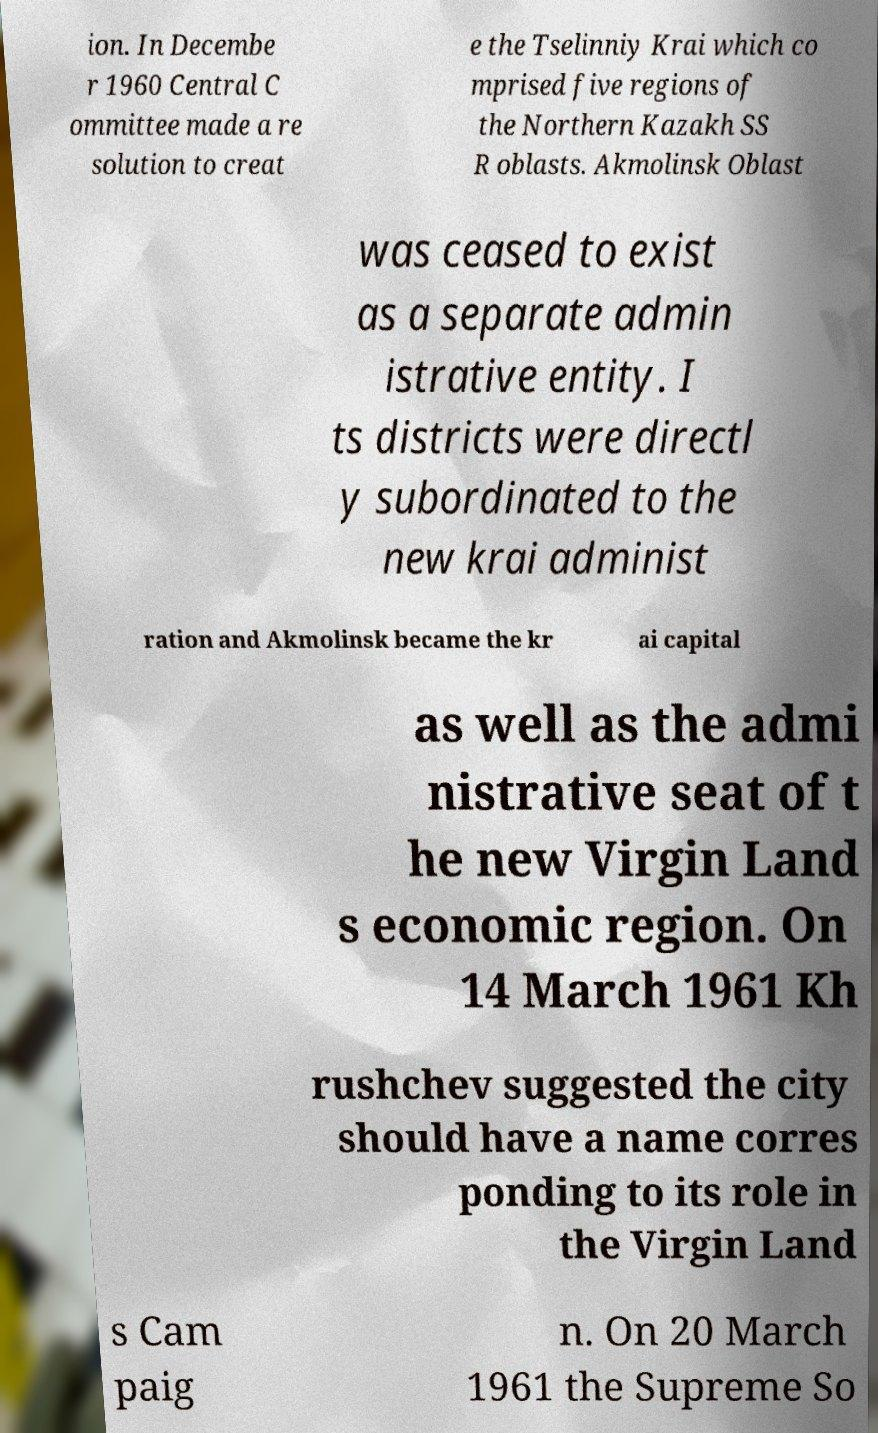Could you extract and type out the text from this image? ion. In Decembe r 1960 Central C ommittee made a re solution to creat e the Tselinniy Krai which co mprised five regions of the Northern Kazakh SS R oblasts. Akmolinsk Oblast was ceased to exist as a separate admin istrative entity. I ts districts were directl y subordinated to the new krai administ ration and Akmolinsk became the kr ai capital as well as the admi nistrative seat of t he new Virgin Land s economic region. On 14 March 1961 Kh rushchev suggested the city should have a name corres ponding to its role in the Virgin Land s Cam paig n. On 20 March 1961 the Supreme So 